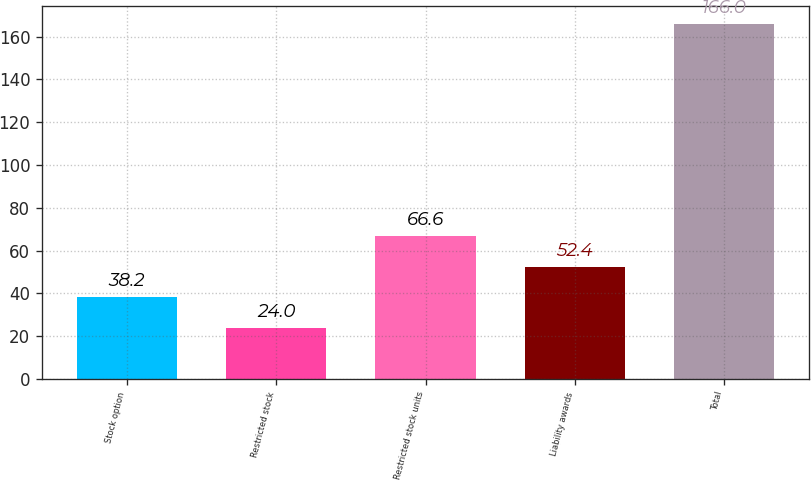Convert chart to OTSL. <chart><loc_0><loc_0><loc_500><loc_500><bar_chart><fcel>Stock option<fcel>Restricted stock<fcel>Restricted stock units<fcel>Liability awards<fcel>Total<nl><fcel>38.2<fcel>24<fcel>66.6<fcel>52.4<fcel>166<nl></chart> 